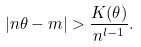<formula> <loc_0><loc_0><loc_500><loc_500>| n \theta - m | > \frac { K ( \theta ) } { n ^ { l - 1 } } .</formula> 